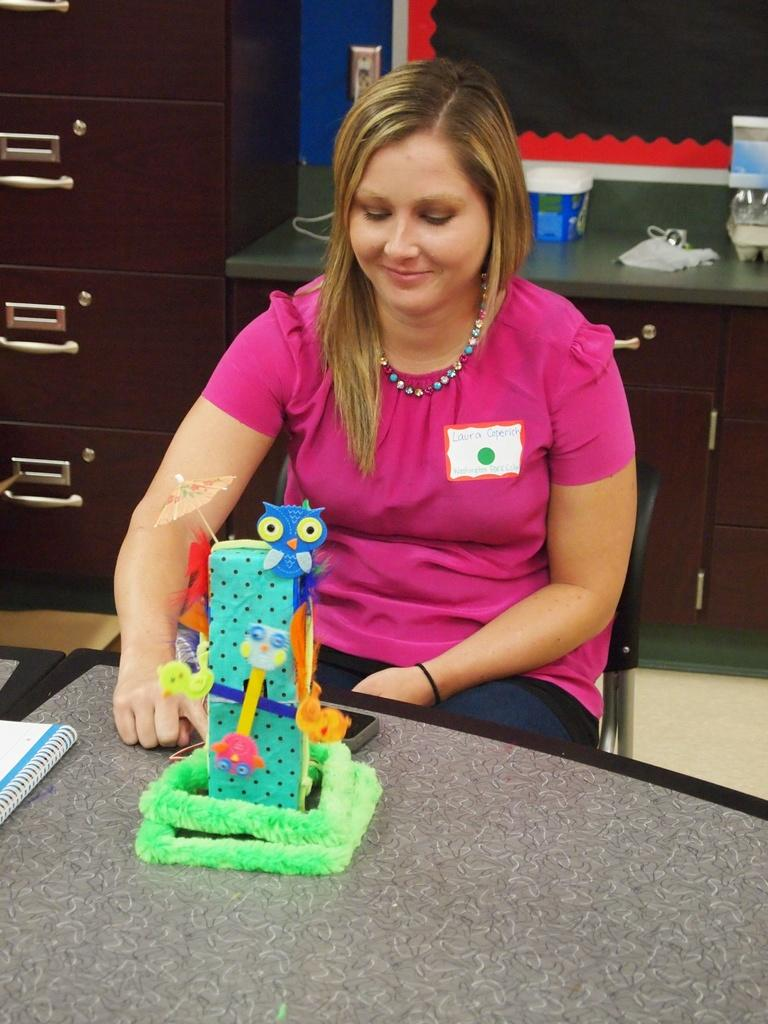What is on the table in the image? There is a book and a toy on the table in the image. What is the woman in the image doing? The woman is sitting on a chair in the image. What can be seen in the background of the image? There are objects on a cabinet and a cupboard in the background. What type of base is the doctor using to fill out the form in the image? There is no doctor or form present in the image; it features a woman sitting on a chair with a book and a toy on the table. What color is the form that the doctor is filling out in the image? There is no form present in the image, so it is not possible to determine its color. 